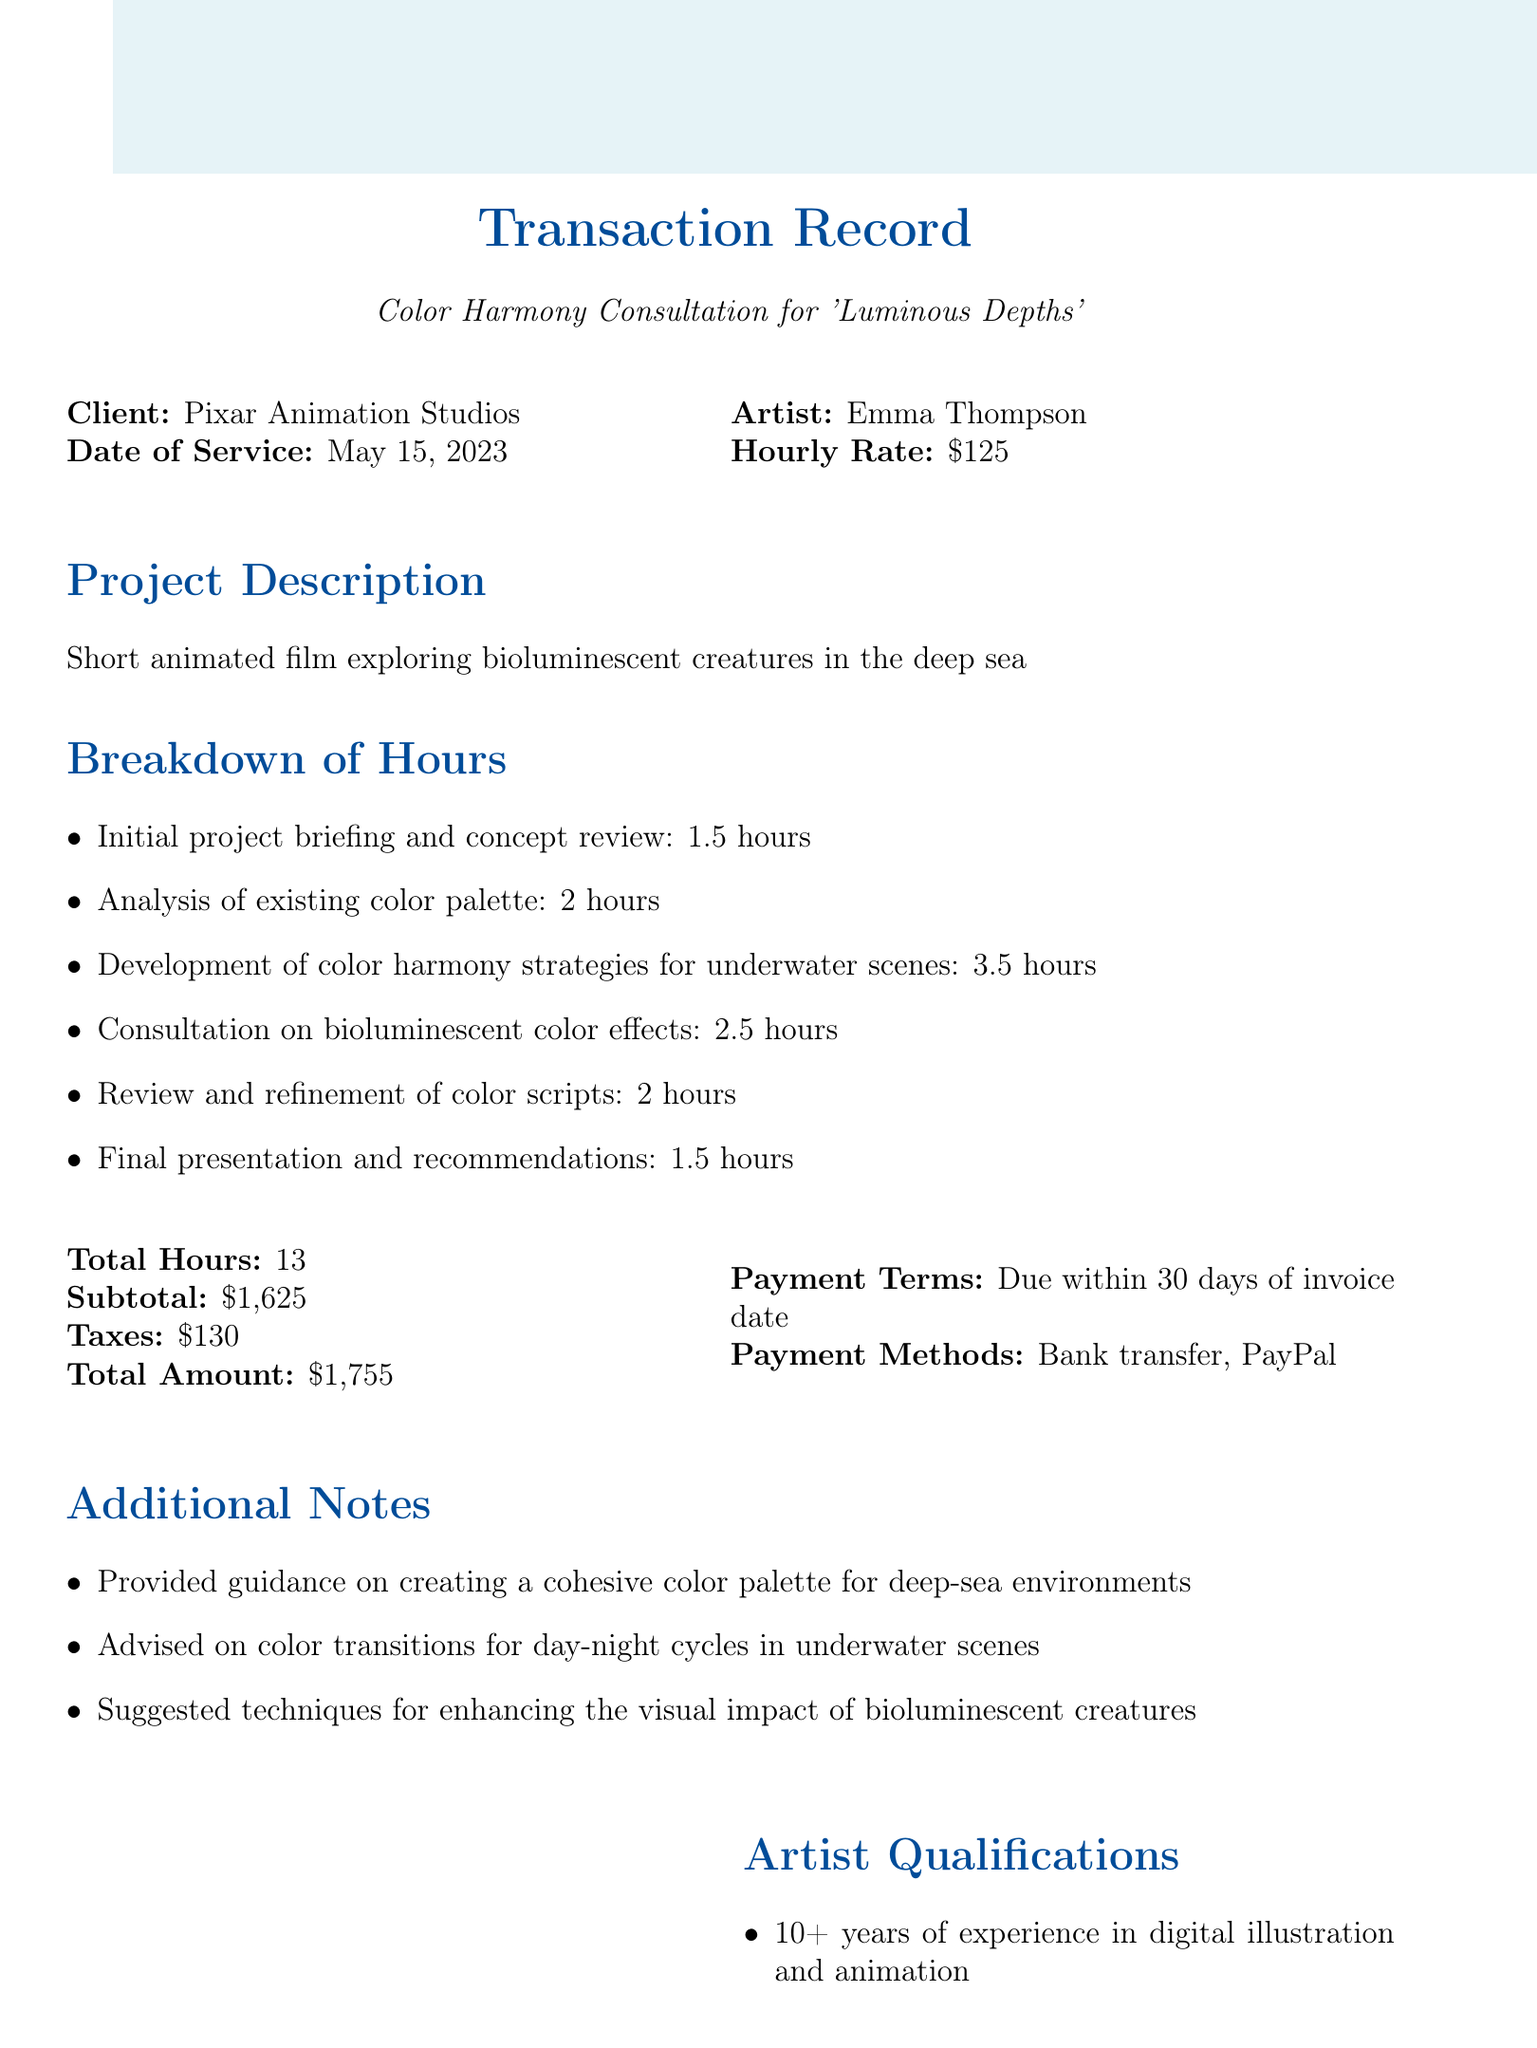What is the client's name? The client's name is stated at the beginning of the document under "Client."
Answer: Pixar Animation Studios What is the date of service? The date of service is listed next to "Date of Service" in the document.
Answer: May 15, 2023 How many total hours were billed for the consultation? The total hours is provided in the "Total Hours" section of the document.
Answer: 13 What was the hourly rate for the services? The hourly rate is mentioned in the section detailing the artist's payment.
Answer: 125 What is the total amount due after taxes? The total amount is provided after the subtotal and tax calculations.
Answer: 1755 Which payment methods are accepted? The payment methods are listed in the "Payment Methods" section of the document.
Answer: Bank transfer, PayPal What task took the longest time during the consultation? The length of each task is outlined within the breakdown of hours, identifying the longest.
Answer: Development of color harmony strategies for underwater scenes How did the client describe Emma's expertise? Client feedback is provided at the end of the document as a direct quotation.
Answer: Significant enhancement of visual storytelling What is one of the qualifications of the artist? The artist qualifications section lists various qualifications of Emma Thompson.
Answer: 10+ years of experience in digital illustration and animation 